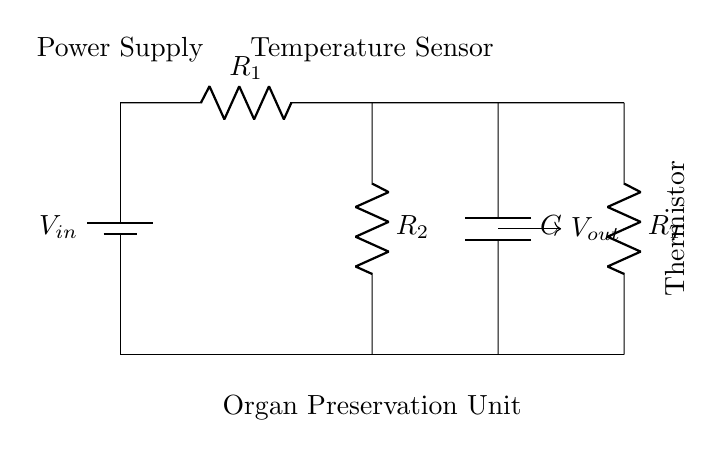What is the input voltage in this circuit? The input voltage is labeled as \( V_{in} \) in the circuit diagram. It refers to the voltage supplied by the battery.
Answer: \( V_{in} \) What is the type of sensor used in this circuit? The circuit contains a temperature sensor, as indicated by the labeling next to the component that is associated with the voltage divider.
Answer: Temperature Sensor How many resistors are in the circuit? The circuit includes two resistors, labeled \( R_1 \) and \( R_2 \), which are part of the voltage divider configuration.
Answer: 2 What is the role of the capacitor in this circuit? The capacitor, labeled \( C \), is integrated into the circuit to manage fluctuations in voltage and provide filtering or smoothing of the output, which is essential for stable readings in temperature monitoring.
Answer: Smoothing What does the thermistor do in this circuit? The thermistor, labeled \( R_T \), provides a variable resistance that changes with temperature, allowing the circuit to monitor temperature by affecting the output voltage.
Answer: Temperature Measurement How is \( V_{out} \) related to \( R_1 \) and \( R_2 \)? The output voltage \( V_{out} \) is determined by the voltage divider rule, which states that it can be calculated as \( V_{out} = V_{in} \times \frac{R_2}{R_1 + R_2} \); therefore, \( V_{out} \) is dependent on the values of resistors \( R_1 \) and \( R_2 \).
Answer: Voltage Divider Rule What function does the power supply serve in this circuit? The power supply, shown as the battery labeled \( V_{in} \), provides the necessary electrical energy to drive the circuit and allow the components to function, enabling the measurement of temperature.
Answer: Provides Power 